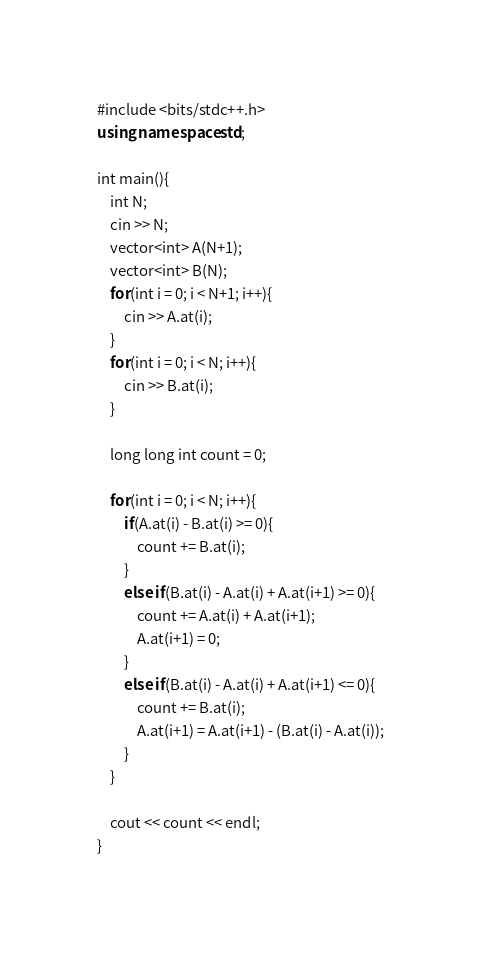<code> <loc_0><loc_0><loc_500><loc_500><_C++_>#include <bits/stdc++.h>
using namespace std;

int main(){
    int N;
    cin >> N;
    vector<int> A(N+1);
    vector<int> B(N);
    for(int i = 0; i < N+1; i++){
        cin >> A.at(i);
    }
    for(int i = 0; i < N; i++){
        cin >> B.at(i);
    }
    
    long long int count = 0;

    for(int i = 0; i < N; i++){
        if(A.at(i) - B.at(i) >= 0){
            count += B.at(i);
        }
        else if(B.at(i) - A.at(i) + A.at(i+1) >= 0){
            count += A.at(i) + A.at(i+1);
            A.at(i+1) = 0;
        }
        else if(B.at(i) - A.at(i) + A.at(i+1) <= 0){
            count += B.at(i);
            A.at(i+1) = A.at(i+1) - (B.at(i) - A.at(i));
        }
    }

    cout << count << endl;
}</code> 